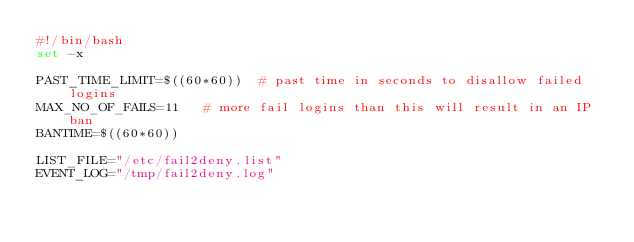Convert code to text. <code><loc_0><loc_0><loc_500><loc_500><_Bash_>#!/bin/bash
set -x

PAST_TIME_LIMIT=$((60*60))  # past time in seconds to disallow failed logins
MAX_NO_OF_FAILS=11   # more fail logins than this will result in an IP ban
BANTIME=$((60*60))

LIST_FILE="/etc/fail2deny.list"
EVENT_LOG="/tmp/fail2deny.log"
</code> 